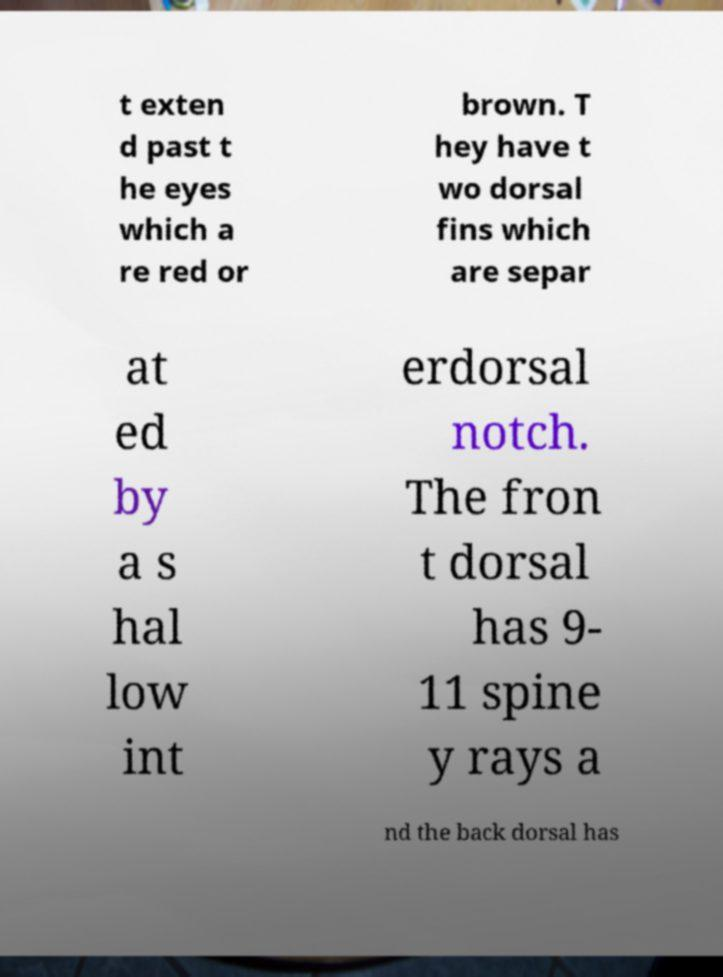Please read and relay the text visible in this image. What does it say? t exten d past t he eyes which a re red or brown. T hey have t wo dorsal fins which are separ at ed by a s hal low int erdorsal notch. The fron t dorsal has 9- 11 spine y rays a nd the back dorsal has 